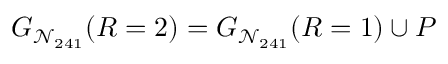Convert formula to latex. <formula><loc_0><loc_0><loc_500><loc_500>G _ { \mathcal { N } _ { 2 4 1 } } ( R = 2 ) = G _ { \mathcal { N } _ { 2 4 1 } } ( R = 1 ) \cup P</formula> 